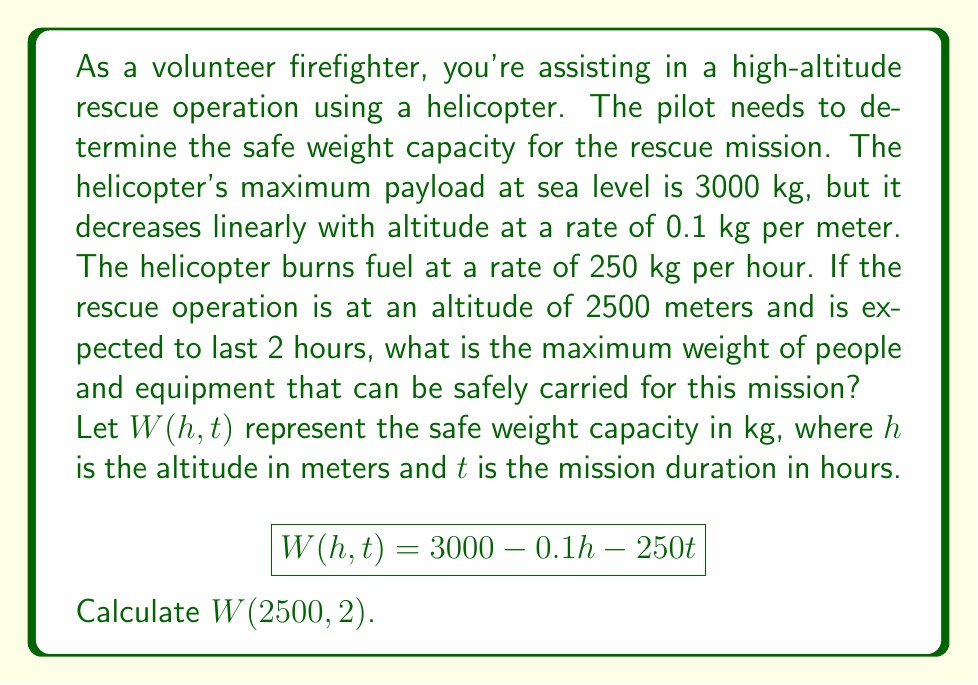What is the answer to this math problem? To solve this problem, we need to follow these steps:

1. Understand the given function:
   $$W(h,t) = 3000 - 0.1h - 250t$$
   Where:
   - 3000 is the maximum payload at sea level in kg
   - 0.1h represents the decrease in payload capacity due to altitude
   - 250t represents the weight of fuel consumed during the mission

2. Insert the given values:
   - Altitude (h) = 2500 meters
   - Mission duration (t) = 2 hours

3. Calculate $W(2500, 2)$:
   $$\begin{align}
   W(2500, 2) &= 3000 - 0.1(2500) - 250(2) \\
   &= 3000 - 250 - 500 \\
   &= 2250
   \end{align}$$

4. Interpret the result:
   The safe weight capacity for this rescue mission is 2250 kg. This represents the maximum weight of people and equipment that can be safely carried, taking into account the altitude of the operation and the fuel consumption for the expected duration of the mission.
Answer: The maximum weight of people and equipment that can be safely carried for this rescue mission is 2250 kg. 